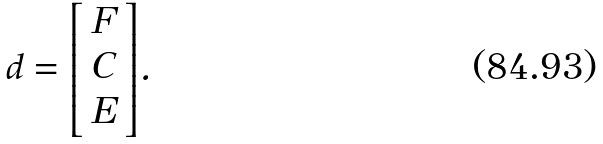Convert formula to latex. <formula><loc_0><loc_0><loc_500><loc_500>d = { \left [ \begin{array} { l } { F } \\ { C } \\ { E } \end{array} \right ] } .</formula> 